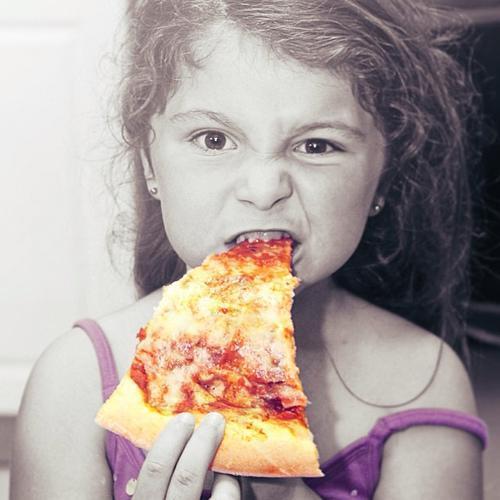How many pieces of pizza are shown?
Give a very brief answer. 1. 